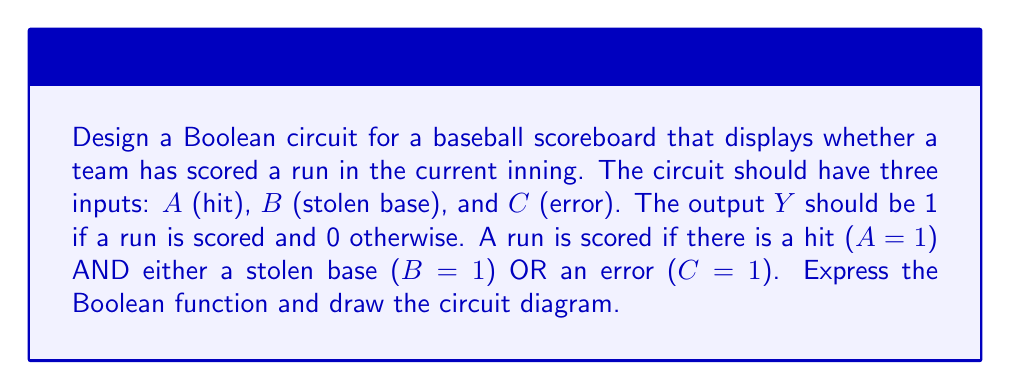Could you help me with this problem? Step 1: Analyze the problem
A run is scored when there is a hit AND (stolen base OR error). This can be translated into Boolean logic.

Step 2: Write the Boolean expression
The Boolean function can be expressed as:
$Y = A \cdot (B + C)$

Step 3: Simplify the expression
This expression is already in its simplest form.

Step 4: Identify the required logic gates
We need:
- One AND gate
- One OR gate

Step 5: Draw the circuit diagram
[asy]
import geometry;

// Define points
pair A = (0,60);
pair B = (0,30);
pair C = (0,0);
pair OR = (40,15);
pair AND = (80,40);
pair Y = (120,40);

// Draw input lines
draw(A--OR+(0,15), arrow=Arrow(TeXHead));
draw(B--OR, arrow=Arrow(TeXHead));
draw(C--OR-(0,15), arrow=Arrow(TeXHead));

// Draw OR gate
draw(OR+(0,-15)--OR+(0,15)--OR+(15,0)--OR+(0,-15));
draw(arc(OR+(15,0),8,270,90));

// Draw connection from OR to AND
draw(OR+(23,0)--(60,15)--(60,30)--AND-(20,0), arrow=Arrow(TeXHead));

// Draw AND gate
draw(AND-(20,-10)--AND-(20,10)--AND+(0,20)--AND+(20,0)--AND+(0,-20)--AND-(20,-10));

// Draw input A to AND gate
draw(A--(60,60)--(60,50)--AND-(0,10), arrow=Arrow(TeXHead));

// Draw output
draw(AND+(20,0)--Y, arrow=Arrow(TeXHead));

// Label inputs and output
label("$A$", A+(5,0), E);
label("$B$", B+(5,0), E);
label("$C$", C+(5,0), E);
label("$Y$", Y+(5,0), E);

[/asy]

Step 6: Explain the circuit operation
1. Inputs $B$ and $C$ are fed into the OR gate.
2. The output of the OR gate $(B+C)$ is then fed into one input of the AND gate.
3. Input $A$ is fed directly into the other input of the AND gate.
4. The output $Y$ of the AND gate represents the final result: whether a run is scored or not.
Answer: $Y = A \cdot (B + C)$ 